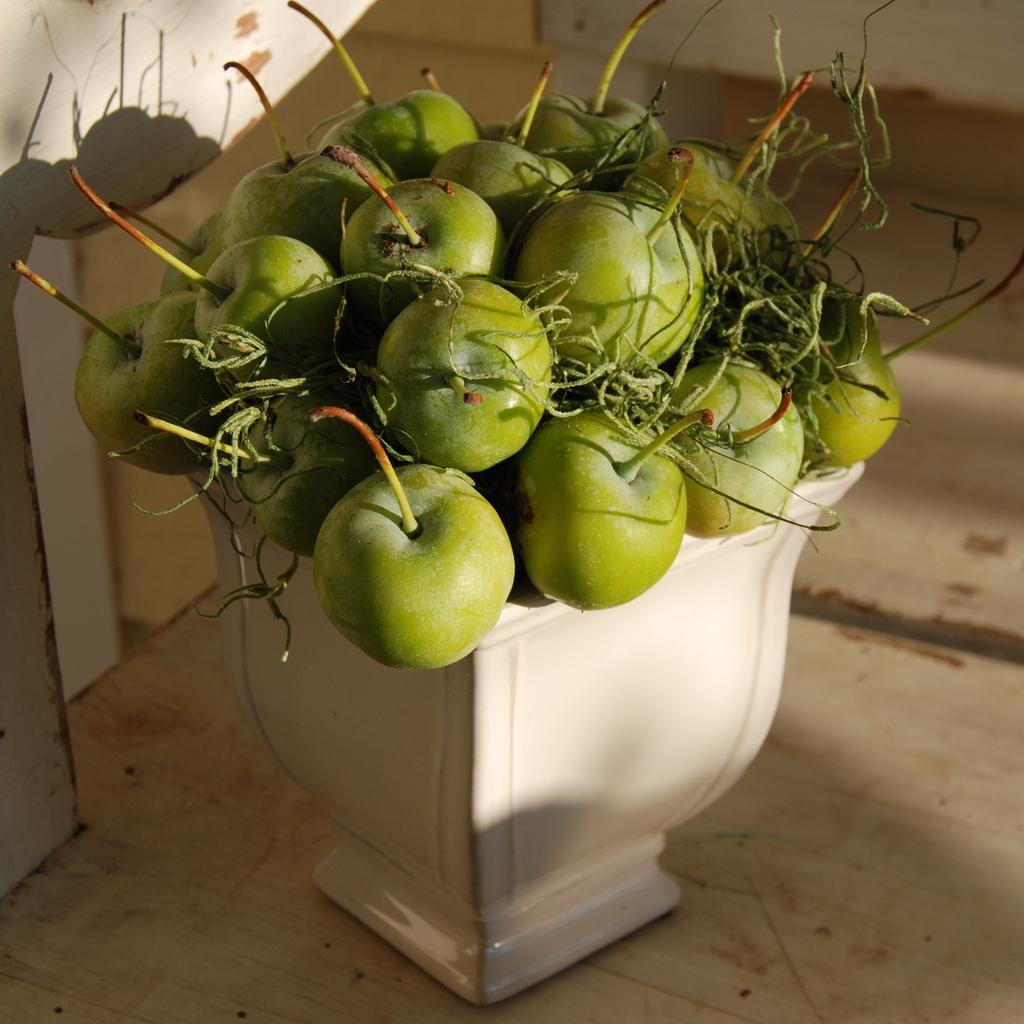What type of fruit is in the ceramic pot in the image? There are apples in a ceramic pot in the image. What can be seen in the background of the image? There is a wall in the background of the image. What type of flooring is visible at the bottom of the image? There is a wooden floor at the bottom of the image. What type of cable can be seen connecting the apples in the image? There is no cable present in the image; it features apples in a ceramic pot with a wall in the background and a wooden floor at the bottom. 